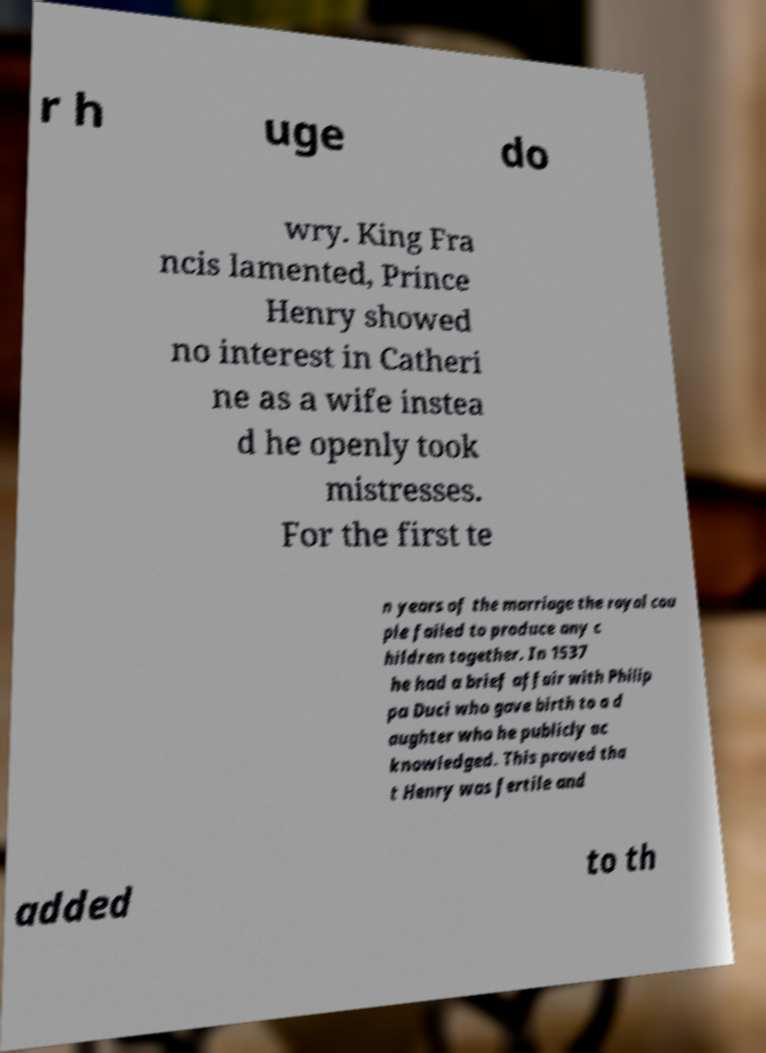Please read and relay the text visible in this image. What does it say? r h uge do wry. King Fra ncis lamented, Prince Henry showed no interest in Catheri ne as a wife instea d he openly took mistresses. For the first te n years of the marriage the royal cou ple failed to produce any c hildren together. In 1537 he had a brief affair with Philip pa Duci who gave birth to a d aughter who he publicly ac knowledged. This proved tha t Henry was fertile and added to th 